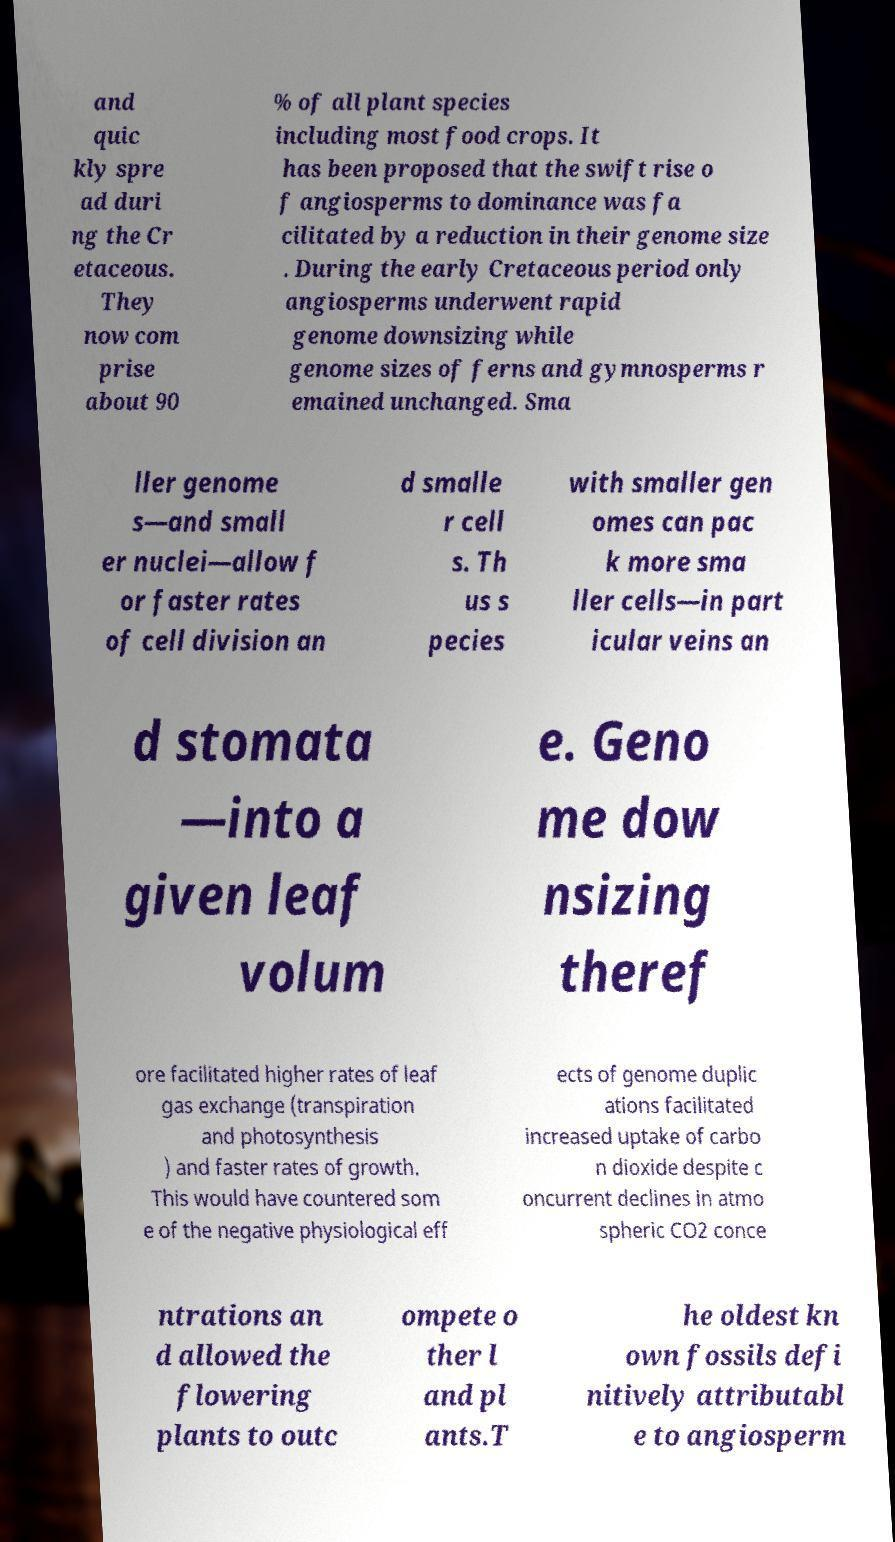For documentation purposes, I need the text within this image transcribed. Could you provide that? and quic kly spre ad duri ng the Cr etaceous. They now com prise about 90 % of all plant species including most food crops. It has been proposed that the swift rise o f angiosperms to dominance was fa cilitated by a reduction in their genome size . During the early Cretaceous period only angiosperms underwent rapid genome downsizing while genome sizes of ferns and gymnosperms r emained unchanged. Sma ller genome s—and small er nuclei—allow f or faster rates of cell division an d smalle r cell s. Th us s pecies with smaller gen omes can pac k more sma ller cells—in part icular veins an d stomata —into a given leaf volum e. Geno me dow nsizing theref ore facilitated higher rates of leaf gas exchange (transpiration and photosynthesis ) and faster rates of growth. This would have countered som e of the negative physiological eff ects of genome duplic ations facilitated increased uptake of carbo n dioxide despite c oncurrent declines in atmo spheric CO2 conce ntrations an d allowed the flowering plants to outc ompete o ther l and pl ants.T he oldest kn own fossils defi nitively attributabl e to angiosperm 